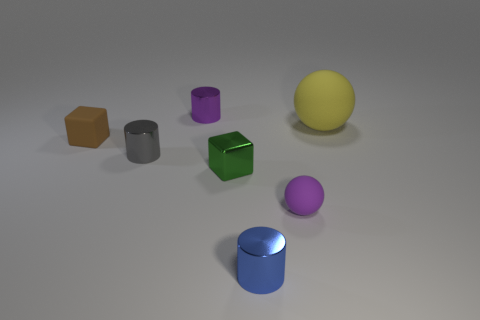There is a object that is both behind the small green shiny block and in front of the brown cube; what is its shape? cylinder 